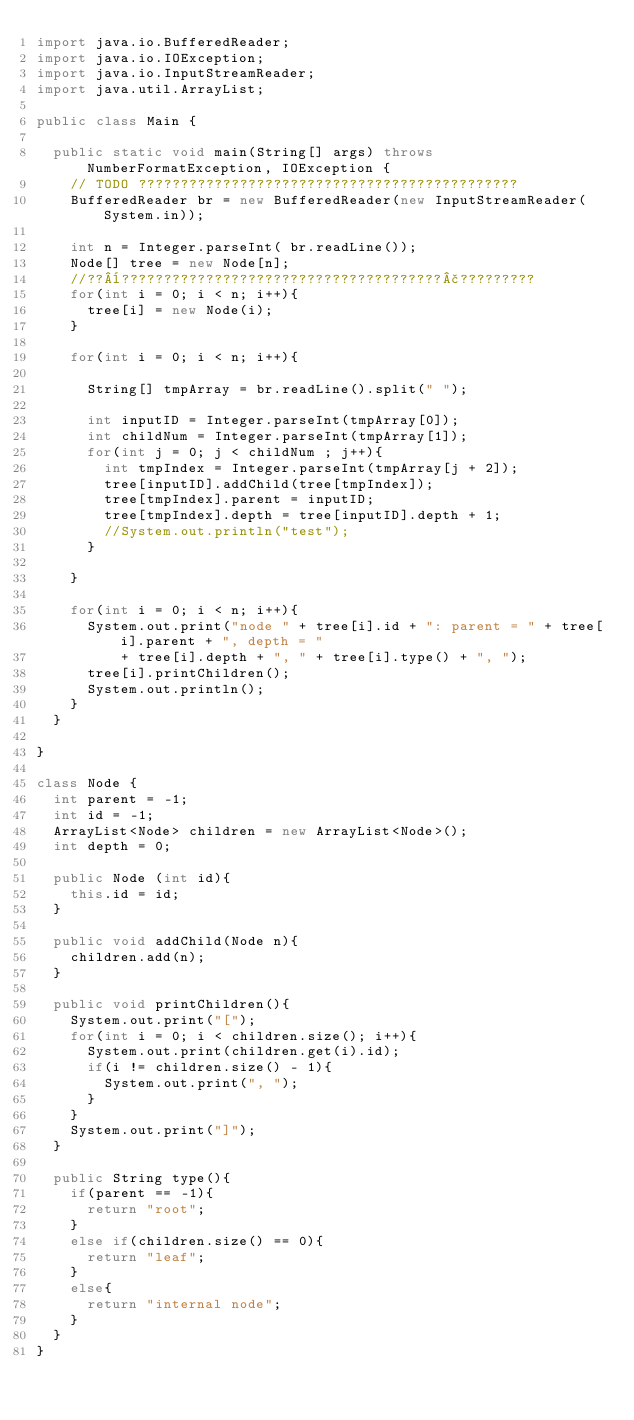<code> <loc_0><loc_0><loc_500><loc_500><_Java_>import java.io.BufferedReader;
import java.io.IOException;
import java.io.InputStreamReader;
import java.util.ArrayList;

public class Main {

	public static void main(String[] args) throws NumberFormatException, IOException {
		// TODO ?????????????????????????????????????????????
		BufferedReader br = new BufferedReader(new InputStreamReader(System.in));

		int n = Integer.parseInt( br.readLine());
		Node[] tree = new Node[n];
		//??¨??????????????????????????????????????£?????????
		for(int i = 0; i < n; i++){
			tree[i] = new Node(i);
		}
		
		for(int i = 0; i < n; i++){
			
			String[] tmpArray = br.readLine().split(" ");
			
			int inputID = Integer.parseInt(tmpArray[0]);
			int childNum = Integer.parseInt(tmpArray[1]);
			for(int j = 0; j < childNum ; j++){
				int tmpIndex = Integer.parseInt(tmpArray[j + 2]);
				tree[inputID].addChild(tree[tmpIndex]);
				tree[tmpIndex].parent = inputID;
				tree[tmpIndex].depth = tree[inputID].depth + 1;
				//System.out.println("test");
			}
			
		}
		
		for(int i = 0; i < n; i++){
			System.out.print("node " + tree[i].id + ": parent = " + tree[i].parent + ", depth = "
					+ tree[i].depth + ", " + tree[i].type() + ", ");
			tree[i].printChildren();
			System.out.println();
		}
	}

}

class Node {
	int parent = -1;
	int id = -1;
	ArrayList<Node> children = new ArrayList<Node>();
	int depth = 0;
	
	public Node (int id){
		this.id = id;
	}
	
	public void addChild(Node n){
		children.add(n);
	}
	
	public void printChildren(){
		System.out.print("[");
		for(int i = 0; i < children.size(); i++){
			System.out.print(children.get(i).id);
			if(i != children.size() - 1){
				System.out.print(", ");
			}
		}
		System.out.print("]");
	}
	
	public String type(){
		if(parent == -1){
			return "root";
		}
		else if(children.size() == 0){
			return "leaf";
		}
		else{
			return "internal node";
		}
	}
}</code> 